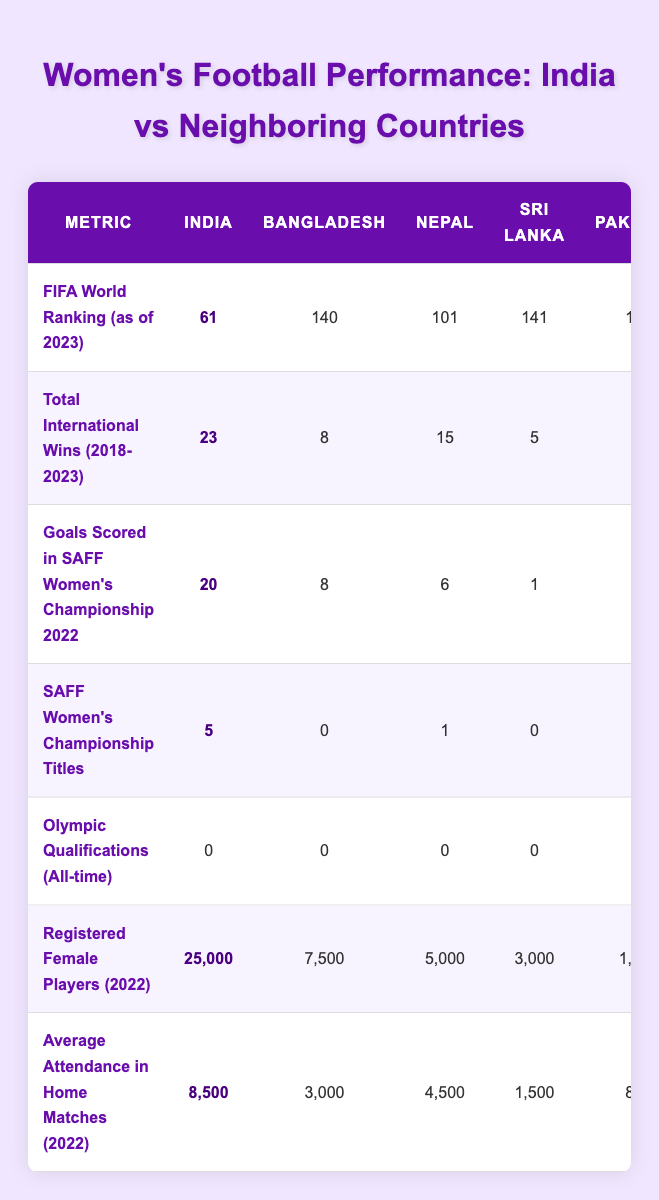What is the FIFA World Ranking of the Indian women's national football team as of 2023? The FIFA World Ranking for India is directly available from the table in the first row under the FIFA World Ranking metric, which states that India is ranked 61.
Answer: 61 How many total international wins did the Indian women's national football team achieve from 2018 to 2023? The total international wins for India are specifically stated in the table under the "Total International Wins (2018-2023)" row, which shows a value of 23.
Answer: 23 Is it true that Bangladesh has more registered female players than Sri Lanka? The table indicates that Bangladesh has 7,500 registered female players while Sri Lanka has 3,000 registered female players. Since 7,500 is greater than 3,000, the statement is true.
Answer: Yes Which country scored the most goals in the SAFF Women's Championship 2022? According to the table under the "Goals Scored in SAFF Women's Championship 2022" metric, India scored 20 goals, which is the highest compared to Bangladesh (8), Nepal (6), Sri Lanka (1), and Pakistan (0).
Answer: India What is the difference in average attendance for home matches between India and Pakistan in 2022? The average attendance for India is 8,500 and for Pakistan, it is 800. To find the difference, subtract Pakistan's average attendance from India's: 8,500 - 800 = 7,700.
Answer: 7,700 How many more SAFF Women's Championship titles does India have compared to Nepal? The table shows that India has 5 titles, while Nepal has 1. To find the difference, subtract Nepal's count from India's: 5 - 1 = 4.
Answer: 4 What is the total number of registered female players across all the listed countries? The total registered female players for each country can be summed up: India (25,000) + Bangladesh (7,500) + Nepal (5,000) + Sri Lanka (3,000) + Pakistan (1,500) = 42,000. This gives a total of 42,000 registered female players.
Answer: 42,000 Does any of the countries listed have Olympic qualifications recorded in the table? The table specifies that all countries, including India, Bangladesh, Nepal, Sri Lanka, and Pakistan, have 0 Olympic qualifications as stated in the "Olympic Qualifications (All-time)" row. Thus, the answer is no.
Answer: No Which country has the lowest FIFA World Ranking? By examining the FIFA World Ranking data, Pakistan has the lowest ranking at 160, as shown in the first row of the table.
Answer: Pakistan How many countries have a total of less than 10 international wins from 2018 to 2023? From the "Total International Wins (2018-2023)" metric, Bangladesh (8), Sri Lanka (5), and Pakistan (2) all have wins less than 10. This makes a total of 3 countries meeting the criteria.
Answer: 3 